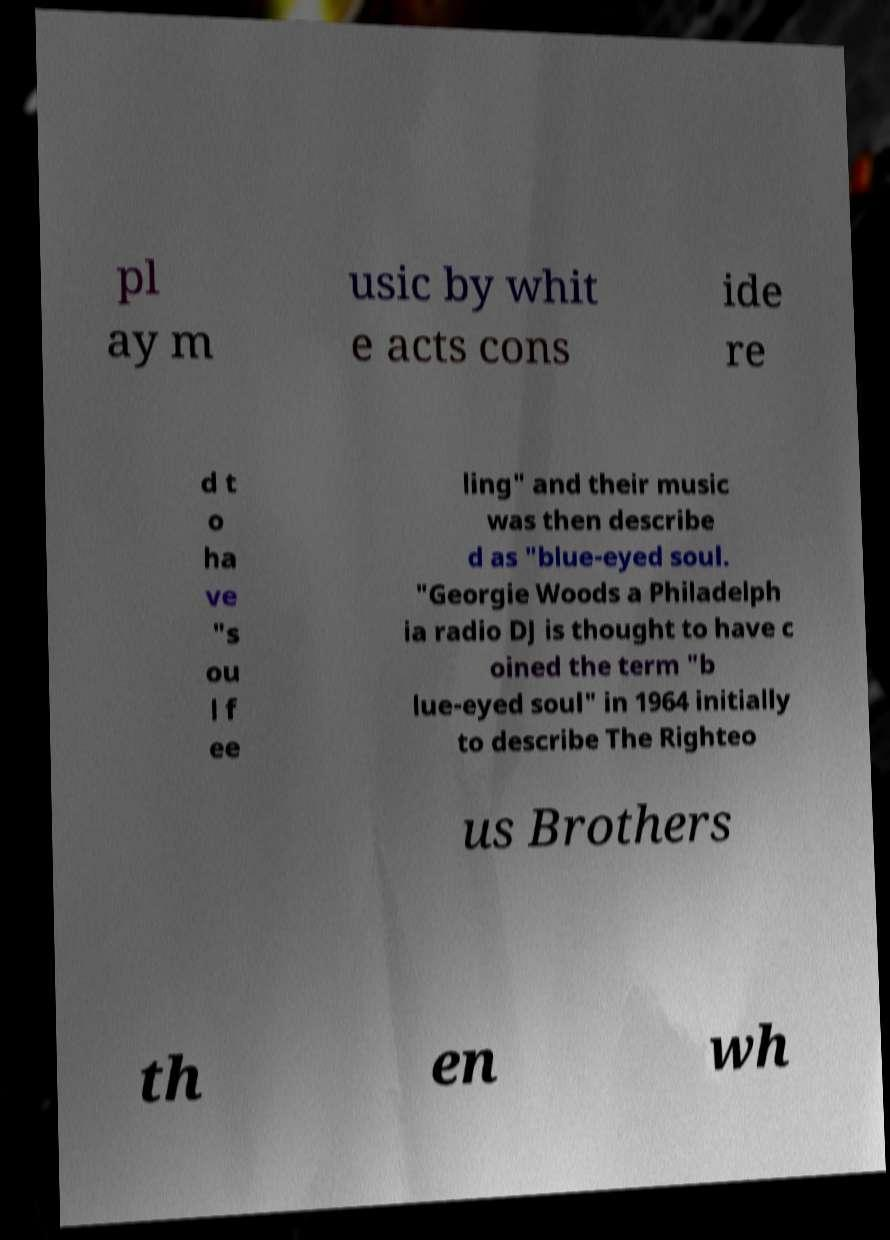I need the written content from this picture converted into text. Can you do that? pl ay m usic by whit e acts cons ide re d t o ha ve "s ou l f ee ling" and their music was then describe d as "blue-eyed soul. "Georgie Woods a Philadelph ia radio DJ is thought to have c oined the term "b lue-eyed soul" in 1964 initially to describe The Righteo us Brothers th en wh 